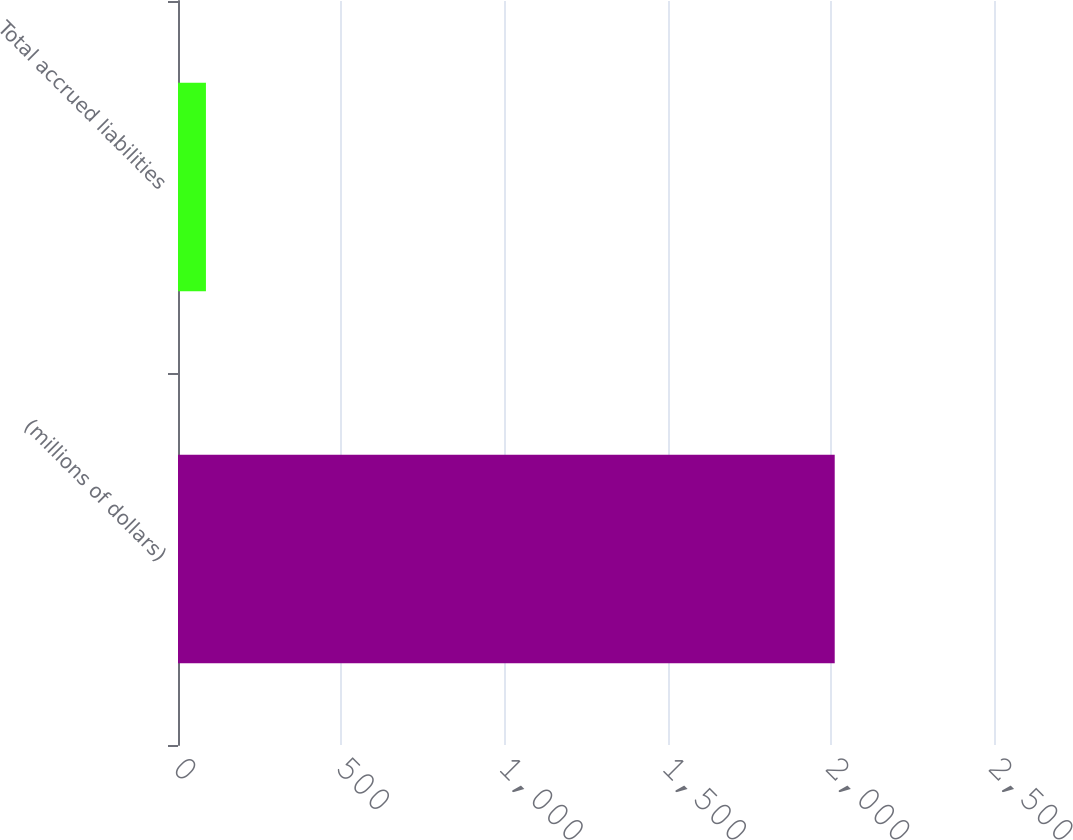Convert chart to OTSL. <chart><loc_0><loc_0><loc_500><loc_500><bar_chart><fcel>(millions of dollars)<fcel>Total accrued liabilities<nl><fcel>2012<fcel>85.6<nl></chart> 